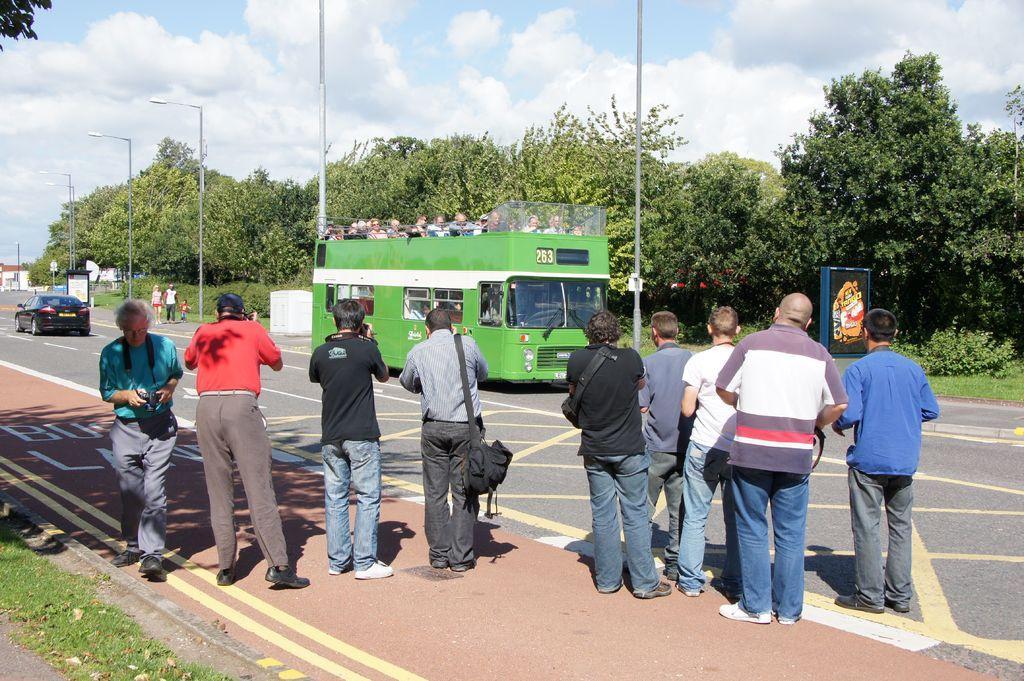Could you give a brief overview of what you see in this image? In this picture, we can see a few people on the road and a few in vehicles, and we can see the road, path, grass, trees, poles, lights building, and we can see the sky with clouds, posters. 